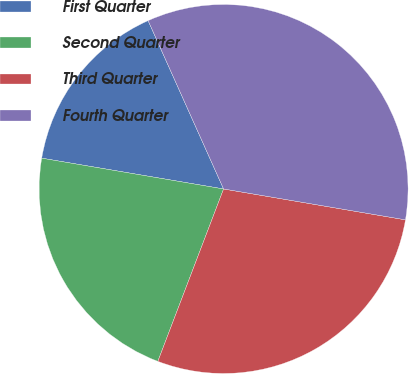Convert chart. <chart><loc_0><loc_0><loc_500><loc_500><pie_chart><fcel>First Quarter<fcel>Second Quarter<fcel>Third Quarter<fcel>Fourth Quarter<nl><fcel>15.62%<fcel>21.87%<fcel>28.12%<fcel>34.38%<nl></chart> 